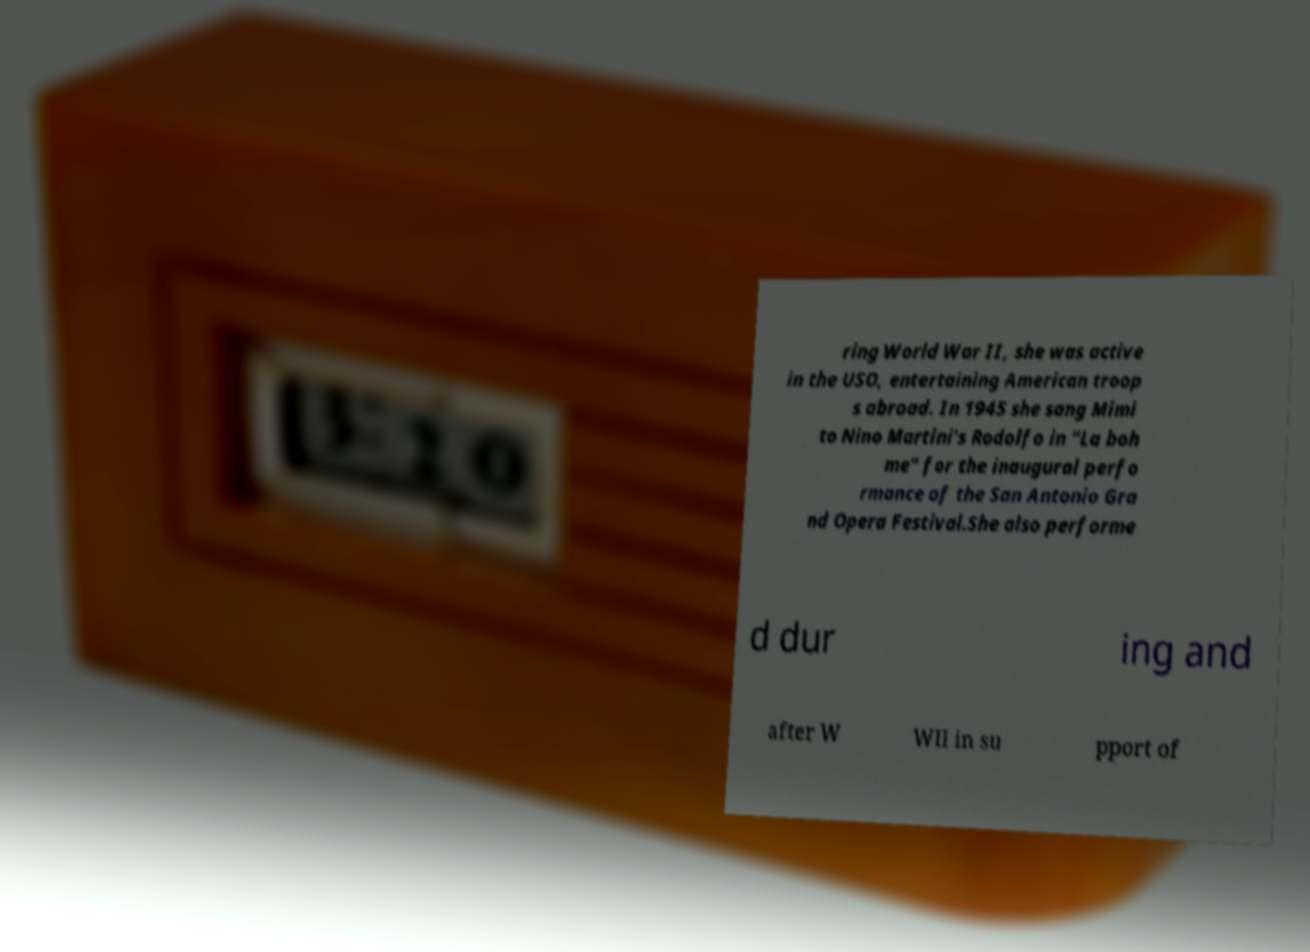Could you extract and type out the text from this image? ring World War II, she was active in the USO, entertaining American troop s abroad. In 1945 she sang Mimi to Nino Martini's Rodolfo in "La boh me" for the inaugural perfo rmance of the San Antonio Gra nd Opera Festival.She also performe d dur ing and after W WII in su pport of 